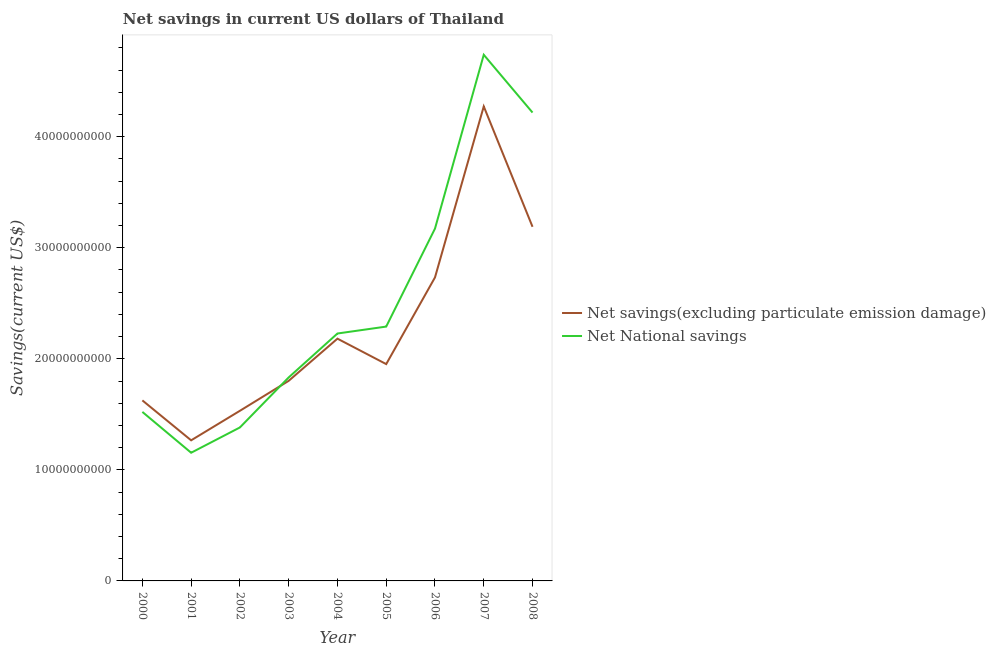Does the line corresponding to net savings(excluding particulate emission damage) intersect with the line corresponding to net national savings?
Offer a very short reply. Yes. What is the net national savings in 2008?
Provide a succinct answer. 4.22e+1. Across all years, what is the maximum net national savings?
Provide a succinct answer. 4.74e+1. Across all years, what is the minimum net national savings?
Keep it short and to the point. 1.15e+1. In which year was the net national savings maximum?
Offer a terse response. 2007. What is the total net savings(excluding particulate emission damage) in the graph?
Make the answer very short. 2.06e+11. What is the difference between the net national savings in 2003 and that in 2005?
Provide a succinct answer. -4.58e+09. What is the difference between the net savings(excluding particulate emission damage) in 2007 and the net national savings in 2002?
Your answer should be very brief. 2.89e+1. What is the average net national savings per year?
Give a very brief answer. 2.50e+1. In the year 2003, what is the difference between the net savings(excluding particulate emission damage) and net national savings?
Offer a very short reply. -3.07e+08. In how many years, is the net savings(excluding particulate emission damage) greater than 4000000000 US$?
Your answer should be compact. 9. What is the ratio of the net national savings in 2001 to that in 2002?
Your response must be concise. 0.84. Is the net national savings in 2000 less than that in 2004?
Offer a very short reply. Yes. Is the difference between the net national savings in 2003 and 2004 greater than the difference between the net savings(excluding particulate emission damage) in 2003 and 2004?
Ensure brevity in your answer.  No. What is the difference between the highest and the second highest net national savings?
Your response must be concise. 5.20e+09. What is the difference between the highest and the lowest net national savings?
Your answer should be very brief. 3.58e+1. Is the sum of the net national savings in 2000 and 2004 greater than the maximum net savings(excluding particulate emission damage) across all years?
Provide a succinct answer. No. Is the net savings(excluding particulate emission damage) strictly less than the net national savings over the years?
Provide a succinct answer. No. How many years are there in the graph?
Make the answer very short. 9. Does the graph contain any zero values?
Ensure brevity in your answer.  No. Does the graph contain grids?
Ensure brevity in your answer.  No. Where does the legend appear in the graph?
Keep it short and to the point. Center right. How many legend labels are there?
Your answer should be compact. 2. What is the title of the graph?
Ensure brevity in your answer.  Net savings in current US dollars of Thailand. Does "Under-five" appear as one of the legend labels in the graph?
Offer a very short reply. No. What is the label or title of the Y-axis?
Make the answer very short. Savings(current US$). What is the Savings(current US$) of Net savings(excluding particulate emission damage) in 2000?
Keep it short and to the point. 1.63e+1. What is the Savings(current US$) in Net National savings in 2000?
Keep it short and to the point. 1.52e+1. What is the Savings(current US$) in Net savings(excluding particulate emission damage) in 2001?
Provide a succinct answer. 1.27e+1. What is the Savings(current US$) of Net National savings in 2001?
Provide a short and direct response. 1.15e+1. What is the Savings(current US$) of Net savings(excluding particulate emission damage) in 2002?
Your answer should be compact. 1.53e+1. What is the Savings(current US$) of Net National savings in 2002?
Your answer should be very brief. 1.38e+1. What is the Savings(current US$) of Net savings(excluding particulate emission damage) in 2003?
Your response must be concise. 1.80e+1. What is the Savings(current US$) of Net National savings in 2003?
Provide a short and direct response. 1.83e+1. What is the Savings(current US$) in Net savings(excluding particulate emission damage) in 2004?
Offer a terse response. 2.18e+1. What is the Savings(current US$) in Net National savings in 2004?
Your answer should be very brief. 2.23e+1. What is the Savings(current US$) in Net savings(excluding particulate emission damage) in 2005?
Your response must be concise. 1.95e+1. What is the Savings(current US$) of Net National savings in 2005?
Offer a very short reply. 2.29e+1. What is the Savings(current US$) in Net savings(excluding particulate emission damage) in 2006?
Provide a succinct answer. 2.73e+1. What is the Savings(current US$) in Net National savings in 2006?
Your answer should be very brief. 3.17e+1. What is the Savings(current US$) in Net savings(excluding particulate emission damage) in 2007?
Your answer should be very brief. 4.27e+1. What is the Savings(current US$) in Net National savings in 2007?
Make the answer very short. 4.74e+1. What is the Savings(current US$) of Net savings(excluding particulate emission damage) in 2008?
Your answer should be compact. 3.19e+1. What is the Savings(current US$) in Net National savings in 2008?
Provide a succinct answer. 4.22e+1. Across all years, what is the maximum Savings(current US$) in Net savings(excluding particulate emission damage)?
Your response must be concise. 4.27e+1. Across all years, what is the maximum Savings(current US$) of Net National savings?
Your response must be concise. 4.74e+1. Across all years, what is the minimum Savings(current US$) in Net savings(excluding particulate emission damage)?
Your answer should be compact. 1.27e+1. Across all years, what is the minimum Savings(current US$) of Net National savings?
Give a very brief answer. 1.15e+1. What is the total Savings(current US$) of Net savings(excluding particulate emission damage) in the graph?
Your answer should be very brief. 2.06e+11. What is the total Savings(current US$) in Net National savings in the graph?
Provide a short and direct response. 2.25e+11. What is the difference between the Savings(current US$) in Net savings(excluding particulate emission damage) in 2000 and that in 2001?
Your answer should be compact. 3.60e+09. What is the difference between the Savings(current US$) in Net National savings in 2000 and that in 2001?
Keep it short and to the point. 3.68e+09. What is the difference between the Savings(current US$) in Net savings(excluding particulate emission damage) in 2000 and that in 2002?
Provide a succinct answer. 9.38e+08. What is the difference between the Savings(current US$) of Net National savings in 2000 and that in 2002?
Your response must be concise. 1.40e+09. What is the difference between the Savings(current US$) in Net savings(excluding particulate emission damage) in 2000 and that in 2003?
Your answer should be very brief. -1.76e+09. What is the difference between the Savings(current US$) of Net National savings in 2000 and that in 2003?
Provide a short and direct response. -3.10e+09. What is the difference between the Savings(current US$) in Net savings(excluding particulate emission damage) in 2000 and that in 2004?
Provide a succinct answer. -5.56e+09. What is the difference between the Savings(current US$) of Net National savings in 2000 and that in 2004?
Provide a succinct answer. -7.06e+09. What is the difference between the Savings(current US$) of Net savings(excluding particulate emission damage) in 2000 and that in 2005?
Keep it short and to the point. -3.27e+09. What is the difference between the Savings(current US$) of Net National savings in 2000 and that in 2005?
Provide a succinct answer. -7.68e+09. What is the difference between the Savings(current US$) of Net savings(excluding particulate emission damage) in 2000 and that in 2006?
Make the answer very short. -1.11e+1. What is the difference between the Savings(current US$) of Net National savings in 2000 and that in 2006?
Your answer should be compact. -1.65e+1. What is the difference between the Savings(current US$) of Net savings(excluding particulate emission damage) in 2000 and that in 2007?
Provide a succinct answer. -2.65e+1. What is the difference between the Savings(current US$) in Net National savings in 2000 and that in 2007?
Give a very brief answer. -3.22e+1. What is the difference between the Savings(current US$) of Net savings(excluding particulate emission damage) in 2000 and that in 2008?
Offer a very short reply. -1.56e+1. What is the difference between the Savings(current US$) in Net National savings in 2000 and that in 2008?
Offer a very short reply. -2.70e+1. What is the difference between the Savings(current US$) in Net savings(excluding particulate emission damage) in 2001 and that in 2002?
Offer a terse response. -2.66e+09. What is the difference between the Savings(current US$) in Net National savings in 2001 and that in 2002?
Your response must be concise. -2.28e+09. What is the difference between the Savings(current US$) in Net savings(excluding particulate emission damage) in 2001 and that in 2003?
Offer a very short reply. -5.36e+09. What is the difference between the Savings(current US$) of Net National savings in 2001 and that in 2003?
Make the answer very short. -6.78e+09. What is the difference between the Savings(current US$) in Net savings(excluding particulate emission damage) in 2001 and that in 2004?
Offer a very short reply. -9.15e+09. What is the difference between the Savings(current US$) of Net National savings in 2001 and that in 2004?
Make the answer very short. -1.07e+1. What is the difference between the Savings(current US$) of Net savings(excluding particulate emission damage) in 2001 and that in 2005?
Provide a short and direct response. -6.86e+09. What is the difference between the Savings(current US$) in Net National savings in 2001 and that in 2005?
Provide a short and direct response. -1.14e+1. What is the difference between the Savings(current US$) in Net savings(excluding particulate emission damage) in 2001 and that in 2006?
Offer a terse response. -1.47e+1. What is the difference between the Savings(current US$) of Net National savings in 2001 and that in 2006?
Keep it short and to the point. -2.02e+1. What is the difference between the Savings(current US$) of Net savings(excluding particulate emission damage) in 2001 and that in 2007?
Ensure brevity in your answer.  -3.01e+1. What is the difference between the Savings(current US$) of Net National savings in 2001 and that in 2007?
Give a very brief answer. -3.58e+1. What is the difference between the Savings(current US$) of Net savings(excluding particulate emission damage) in 2001 and that in 2008?
Ensure brevity in your answer.  -1.92e+1. What is the difference between the Savings(current US$) of Net National savings in 2001 and that in 2008?
Give a very brief answer. -3.06e+1. What is the difference between the Savings(current US$) of Net savings(excluding particulate emission damage) in 2002 and that in 2003?
Keep it short and to the point. -2.70e+09. What is the difference between the Savings(current US$) of Net National savings in 2002 and that in 2003?
Provide a succinct answer. -4.50e+09. What is the difference between the Savings(current US$) of Net savings(excluding particulate emission damage) in 2002 and that in 2004?
Your answer should be compact. -6.50e+09. What is the difference between the Savings(current US$) of Net National savings in 2002 and that in 2004?
Your answer should be very brief. -8.46e+09. What is the difference between the Savings(current US$) in Net savings(excluding particulate emission damage) in 2002 and that in 2005?
Offer a terse response. -4.20e+09. What is the difference between the Savings(current US$) in Net National savings in 2002 and that in 2005?
Ensure brevity in your answer.  -9.08e+09. What is the difference between the Savings(current US$) of Net savings(excluding particulate emission damage) in 2002 and that in 2006?
Make the answer very short. -1.20e+1. What is the difference between the Savings(current US$) of Net National savings in 2002 and that in 2006?
Your answer should be compact. -1.79e+1. What is the difference between the Savings(current US$) of Net savings(excluding particulate emission damage) in 2002 and that in 2007?
Your response must be concise. -2.74e+1. What is the difference between the Savings(current US$) in Net National savings in 2002 and that in 2007?
Your answer should be compact. -3.36e+1. What is the difference between the Savings(current US$) of Net savings(excluding particulate emission damage) in 2002 and that in 2008?
Give a very brief answer. -1.66e+1. What is the difference between the Savings(current US$) in Net National savings in 2002 and that in 2008?
Make the answer very short. -2.84e+1. What is the difference between the Savings(current US$) of Net savings(excluding particulate emission damage) in 2003 and that in 2004?
Give a very brief answer. -3.80e+09. What is the difference between the Savings(current US$) of Net National savings in 2003 and that in 2004?
Your answer should be very brief. -3.95e+09. What is the difference between the Savings(current US$) of Net savings(excluding particulate emission damage) in 2003 and that in 2005?
Your answer should be very brief. -1.51e+09. What is the difference between the Savings(current US$) of Net National savings in 2003 and that in 2005?
Your answer should be compact. -4.58e+09. What is the difference between the Savings(current US$) of Net savings(excluding particulate emission damage) in 2003 and that in 2006?
Your response must be concise. -9.31e+09. What is the difference between the Savings(current US$) in Net National savings in 2003 and that in 2006?
Ensure brevity in your answer.  -1.34e+1. What is the difference between the Savings(current US$) of Net savings(excluding particulate emission damage) in 2003 and that in 2007?
Provide a short and direct response. -2.47e+1. What is the difference between the Savings(current US$) in Net National savings in 2003 and that in 2007?
Keep it short and to the point. -2.91e+1. What is the difference between the Savings(current US$) in Net savings(excluding particulate emission damage) in 2003 and that in 2008?
Give a very brief answer. -1.39e+1. What is the difference between the Savings(current US$) in Net National savings in 2003 and that in 2008?
Your answer should be very brief. -2.38e+1. What is the difference between the Savings(current US$) in Net savings(excluding particulate emission damage) in 2004 and that in 2005?
Your answer should be compact. 2.29e+09. What is the difference between the Savings(current US$) in Net National savings in 2004 and that in 2005?
Give a very brief answer. -6.24e+08. What is the difference between the Savings(current US$) in Net savings(excluding particulate emission damage) in 2004 and that in 2006?
Keep it short and to the point. -5.51e+09. What is the difference between the Savings(current US$) of Net National savings in 2004 and that in 2006?
Offer a terse response. -9.45e+09. What is the difference between the Savings(current US$) in Net savings(excluding particulate emission damage) in 2004 and that in 2007?
Make the answer very short. -2.09e+1. What is the difference between the Savings(current US$) of Net National savings in 2004 and that in 2007?
Your response must be concise. -2.51e+1. What is the difference between the Savings(current US$) in Net savings(excluding particulate emission damage) in 2004 and that in 2008?
Give a very brief answer. -1.01e+1. What is the difference between the Savings(current US$) of Net National savings in 2004 and that in 2008?
Offer a terse response. -1.99e+1. What is the difference between the Savings(current US$) in Net savings(excluding particulate emission damage) in 2005 and that in 2006?
Your answer should be very brief. -7.80e+09. What is the difference between the Savings(current US$) in Net National savings in 2005 and that in 2006?
Your answer should be compact. -8.82e+09. What is the difference between the Savings(current US$) in Net savings(excluding particulate emission damage) in 2005 and that in 2007?
Your response must be concise. -2.32e+1. What is the difference between the Savings(current US$) in Net National savings in 2005 and that in 2007?
Give a very brief answer. -2.45e+1. What is the difference between the Savings(current US$) in Net savings(excluding particulate emission damage) in 2005 and that in 2008?
Offer a terse response. -1.24e+1. What is the difference between the Savings(current US$) of Net National savings in 2005 and that in 2008?
Keep it short and to the point. -1.93e+1. What is the difference between the Savings(current US$) of Net savings(excluding particulate emission damage) in 2006 and that in 2007?
Give a very brief answer. -1.54e+1. What is the difference between the Savings(current US$) of Net National savings in 2006 and that in 2007?
Give a very brief answer. -1.57e+1. What is the difference between the Savings(current US$) of Net savings(excluding particulate emission damage) in 2006 and that in 2008?
Provide a short and direct response. -4.56e+09. What is the difference between the Savings(current US$) of Net National savings in 2006 and that in 2008?
Your response must be concise. -1.04e+1. What is the difference between the Savings(current US$) of Net savings(excluding particulate emission damage) in 2007 and that in 2008?
Keep it short and to the point. 1.08e+1. What is the difference between the Savings(current US$) of Net National savings in 2007 and that in 2008?
Provide a short and direct response. 5.20e+09. What is the difference between the Savings(current US$) of Net savings(excluding particulate emission damage) in 2000 and the Savings(current US$) of Net National savings in 2001?
Your response must be concise. 4.71e+09. What is the difference between the Savings(current US$) in Net savings(excluding particulate emission damage) in 2000 and the Savings(current US$) in Net National savings in 2002?
Give a very brief answer. 2.44e+09. What is the difference between the Savings(current US$) in Net savings(excluding particulate emission damage) in 2000 and the Savings(current US$) in Net National savings in 2003?
Make the answer very short. -2.07e+09. What is the difference between the Savings(current US$) in Net savings(excluding particulate emission damage) in 2000 and the Savings(current US$) in Net National savings in 2004?
Your answer should be very brief. -6.02e+09. What is the difference between the Savings(current US$) of Net savings(excluding particulate emission damage) in 2000 and the Savings(current US$) of Net National savings in 2005?
Your response must be concise. -6.65e+09. What is the difference between the Savings(current US$) of Net savings(excluding particulate emission damage) in 2000 and the Savings(current US$) of Net National savings in 2006?
Your answer should be compact. -1.55e+1. What is the difference between the Savings(current US$) in Net savings(excluding particulate emission damage) in 2000 and the Savings(current US$) in Net National savings in 2007?
Ensure brevity in your answer.  -3.11e+1. What is the difference between the Savings(current US$) of Net savings(excluding particulate emission damage) in 2000 and the Savings(current US$) of Net National savings in 2008?
Ensure brevity in your answer.  -2.59e+1. What is the difference between the Savings(current US$) of Net savings(excluding particulate emission damage) in 2001 and the Savings(current US$) of Net National savings in 2002?
Ensure brevity in your answer.  -1.16e+09. What is the difference between the Savings(current US$) in Net savings(excluding particulate emission damage) in 2001 and the Savings(current US$) in Net National savings in 2003?
Your answer should be compact. -5.66e+09. What is the difference between the Savings(current US$) of Net savings(excluding particulate emission damage) in 2001 and the Savings(current US$) of Net National savings in 2004?
Provide a short and direct response. -9.62e+09. What is the difference between the Savings(current US$) of Net savings(excluding particulate emission damage) in 2001 and the Savings(current US$) of Net National savings in 2005?
Your response must be concise. -1.02e+1. What is the difference between the Savings(current US$) in Net savings(excluding particulate emission damage) in 2001 and the Savings(current US$) in Net National savings in 2006?
Provide a succinct answer. -1.91e+1. What is the difference between the Savings(current US$) of Net savings(excluding particulate emission damage) in 2001 and the Savings(current US$) of Net National savings in 2007?
Make the answer very short. -3.47e+1. What is the difference between the Savings(current US$) in Net savings(excluding particulate emission damage) in 2001 and the Savings(current US$) in Net National savings in 2008?
Provide a succinct answer. -2.95e+1. What is the difference between the Savings(current US$) of Net savings(excluding particulate emission damage) in 2002 and the Savings(current US$) of Net National savings in 2003?
Your response must be concise. -3.00e+09. What is the difference between the Savings(current US$) in Net savings(excluding particulate emission damage) in 2002 and the Savings(current US$) in Net National savings in 2004?
Provide a short and direct response. -6.96e+09. What is the difference between the Savings(current US$) of Net savings(excluding particulate emission damage) in 2002 and the Savings(current US$) of Net National savings in 2005?
Your response must be concise. -7.58e+09. What is the difference between the Savings(current US$) of Net savings(excluding particulate emission damage) in 2002 and the Savings(current US$) of Net National savings in 2006?
Your response must be concise. -1.64e+1. What is the difference between the Savings(current US$) in Net savings(excluding particulate emission damage) in 2002 and the Savings(current US$) in Net National savings in 2007?
Offer a very short reply. -3.21e+1. What is the difference between the Savings(current US$) of Net savings(excluding particulate emission damage) in 2002 and the Savings(current US$) of Net National savings in 2008?
Make the answer very short. -2.69e+1. What is the difference between the Savings(current US$) in Net savings(excluding particulate emission damage) in 2003 and the Savings(current US$) in Net National savings in 2004?
Your response must be concise. -4.26e+09. What is the difference between the Savings(current US$) of Net savings(excluding particulate emission damage) in 2003 and the Savings(current US$) of Net National savings in 2005?
Offer a very short reply. -4.89e+09. What is the difference between the Savings(current US$) of Net savings(excluding particulate emission damage) in 2003 and the Savings(current US$) of Net National savings in 2006?
Provide a succinct answer. -1.37e+1. What is the difference between the Savings(current US$) in Net savings(excluding particulate emission damage) in 2003 and the Savings(current US$) in Net National savings in 2007?
Make the answer very short. -2.94e+1. What is the difference between the Savings(current US$) of Net savings(excluding particulate emission damage) in 2003 and the Savings(current US$) of Net National savings in 2008?
Provide a short and direct response. -2.42e+1. What is the difference between the Savings(current US$) in Net savings(excluding particulate emission damage) in 2004 and the Savings(current US$) in Net National savings in 2005?
Give a very brief answer. -1.09e+09. What is the difference between the Savings(current US$) in Net savings(excluding particulate emission damage) in 2004 and the Savings(current US$) in Net National savings in 2006?
Your response must be concise. -9.91e+09. What is the difference between the Savings(current US$) of Net savings(excluding particulate emission damage) in 2004 and the Savings(current US$) of Net National savings in 2007?
Your response must be concise. -2.56e+1. What is the difference between the Savings(current US$) in Net savings(excluding particulate emission damage) in 2004 and the Savings(current US$) in Net National savings in 2008?
Make the answer very short. -2.04e+1. What is the difference between the Savings(current US$) in Net savings(excluding particulate emission damage) in 2005 and the Savings(current US$) in Net National savings in 2006?
Your answer should be very brief. -1.22e+1. What is the difference between the Savings(current US$) in Net savings(excluding particulate emission damage) in 2005 and the Savings(current US$) in Net National savings in 2007?
Keep it short and to the point. -2.79e+1. What is the difference between the Savings(current US$) in Net savings(excluding particulate emission damage) in 2005 and the Savings(current US$) in Net National savings in 2008?
Keep it short and to the point. -2.26e+1. What is the difference between the Savings(current US$) in Net savings(excluding particulate emission damage) in 2006 and the Savings(current US$) in Net National savings in 2007?
Provide a succinct answer. -2.00e+1. What is the difference between the Savings(current US$) in Net savings(excluding particulate emission damage) in 2006 and the Savings(current US$) in Net National savings in 2008?
Provide a succinct answer. -1.48e+1. What is the difference between the Savings(current US$) of Net savings(excluding particulate emission damage) in 2007 and the Savings(current US$) of Net National savings in 2008?
Give a very brief answer. 5.54e+08. What is the average Savings(current US$) in Net savings(excluding particulate emission damage) per year?
Your response must be concise. 2.28e+1. What is the average Savings(current US$) of Net National savings per year?
Offer a terse response. 2.50e+1. In the year 2000, what is the difference between the Savings(current US$) in Net savings(excluding particulate emission damage) and Savings(current US$) in Net National savings?
Ensure brevity in your answer.  1.04e+09. In the year 2001, what is the difference between the Savings(current US$) of Net savings(excluding particulate emission damage) and Savings(current US$) of Net National savings?
Keep it short and to the point. 1.12e+09. In the year 2002, what is the difference between the Savings(current US$) of Net savings(excluding particulate emission damage) and Savings(current US$) of Net National savings?
Your response must be concise. 1.50e+09. In the year 2003, what is the difference between the Savings(current US$) in Net savings(excluding particulate emission damage) and Savings(current US$) in Net National savings?
Offer a terse response. -3.07e+08. In the year 2004, what is the difference between the Savings(current US$) of Net savings(excluding particulate emission damage) and Savings(current US$) of Net National savings?
Keep it short and to the point. -4.63e+08. In the year 2005, what is the difference between the Savings(current US$) of Net savings(excluding particulate emission damage) and Savings(current US$) of Net National savings?
Make the answer very short. -3.38e+09. In the year 2006, what is the difference between the Savings(current US$) in Net savings(excluding particulate emission damage) and Savings(current US$) in Net National savings?
Make the answer very short. -4.40e+09. In the year 2007, what is the difference between the Savings(current US$) in Net savings(excluding particulate emission damage) and Savings(current US$) in Net National savings?
Keep it short and to the point. -4.65e+09. In the year 2008, what is the difference between the Savings(current US$) in Net savings(excluding particulate emission damage) and Savings(current US$) in Net National savings?
Offer a very short reply. -1.03e+1. What is the ratio of the Savings(current US$) of Net savings(excluding particulate emission damage) in 2000 to that in 2001?
Offer a terse response. 1.28. What is the ratio of the Savings(current US$) of Net National savings in 2000 to that in 2001?
Provide a succinct answer. 1.32. What is the ratio of the Savings(current US$) in Net savings(excluding particulate emission damage) in 2000 to that in 2002?
Provide a succinct answer. 1.06. What is the ratio of the Savings(current US$) of Net National savings in 2000 to that in 2002?
Offer a terse response. 1.1. What is the ratio of the Savings(current US$) in Net savings(excluding particulate emission damage) in 2000 to that in 2003?
Your answer should be compact. 0.9. What is the ratio of the Savings(current US$) of Net National savings in 2000 to that in 2003?
Offer a very short reply. 0.83. What is the ratio of the Savings(current US$) in Net savings(excluding particulate emission damage) in 2000 to that in 2004?
Keep it short and to the point. 0.75. What is the ratio of the Savings(current US$) in Net National savings in 2000 to that in 2004?
Make the answer very short. 0.68. What is the ratio of the Savings(current US$) of Net savings(excluding particulate emission damage) in 2000 to that in 2005?
Provide a short and direct response. 0.83. What is the ratio of the Savings(current US$) of Net National savings in 2000 to that in 2005?
Provide a succinct answer. 0.66. What is the ratio of the Savings(current US$) of Net savings(excluding particulate emission damage) in 2000 to that in 2006?
Give a very brief answer. 0.59. What is the ratio of the Savings(current US$) in Net National savings in 2000 to that in 2006?
Your answer should be compact. 0.48. What is the ratio of the Savings(current US$) in Net savings(excluding particulate emission damage) in 2000 to that in 2007?
Give a very brief answer. 0.38. What is the ratio of the Savings(current US$) of Net National savings in 2000 to that in 2007?
Your answer should be very brief. 0.32. What is the ratio of the Savings(current US$) of Net savings(excluding particulate emission damage) in 2000 to that in 2008?
Offer a terse response. 0.51. What is the ratio of the Savings(current US$) of Net National savings in 2000 to that in 2008?
Your response must be concise. 0.36. What is the ratio of the Savings(current US$) of Net savings(excluding particulate emission damage) in 2001 to that in 2002?
Offer a terse response. 0.83. What is the ratio of the Savings(current US$) of Net National savings in 2001 to that in 2002?
Give a very brief answer. 0.84. What is the ratio of the Savings(current US$) in Net savings(excluding particulate emission damage) in 2001 to that in 2003?
Offer a terse response. 0.7. What is the ratio of the Savings(current US$) in Net National savings in 2001 to that in 2003?
Make the answer very short. 0.63. What is the ratio of the Savings(current US$) of Net savings(excluding particulate emission damage) in 2001 to that in 2004?
Ensure brevity in your answer.  0.58. What is the ratio of the Savings(current US$) of Net National savings in 2001 to that in 2004?
Your answer should be compact. 0.52. What is the ratio of the Savings(current US$) of Net savings(excluding particulate emission damage) in 2001 to that in 2005?
Your answer should be very brief. 0.65. What is the ratio of the Savings(current US$) in Net National savings in 2001 to that in 2005?
Keep it short and to the point. 0.5. What is the ratio of the Savings(current US$) in Net savings(excluding particulate emission damage) in 2001 to that in 2006?
Provide a short and direct response. 0.46. What is the ratio of the Savings(current US$) of Net National savings in 2001 to that in 2006?
Provide a succinct answer. 0.36. What is the ratio of the Savings(current US$) of Net savings(excluding particulate emission damage) in 2001 to that in 2007?
Keep it short and to the point. 0.3. What is the ratio of the Savings(current US$) in Net National savings in 2001 to that in 2007?
Provide a succinct answer. 0.24. What is the ratio of the Savings(current US$) of Net savings(excluding particulate emission damage) in 2001 to that in 2008?
Offer a terse response. 0.4. What is the ratio of the Savings(current US$) in Net National savings in 2001 to that in 2008?
Offer a terse response. 0.27. What is the ratio of the Savings(current US$) in Net savings(excluding particulate emission damage) in 2002 to that in 2003?
Offer a very short reply. 0.85. What is the ratio of the Savings(current US$) in Net National savings in 2002 to that in 2003?
Provide a short and direct response. 0.75. What is the ratio of the Savings(current US$) of Net savings(excluding particulate emission damage) in 2002 to that in 2004?
Provide a succinct answer. 0.7. What is the ratio of the Savings(current US$) in Net National savings in 2002 to that in 2004?
Give a very brief answer. 0.62. What is the ratio of the Savings(current US$) of Net savings(excluding particulate emission damage) in 2002 to that in 2005?
Your answer should be very brief. 0.78. What is the ratio of the Savings(current US$) of Net National savings in 2002 to that in 2005?
Provide a short and direct response. 0.6. What is the ratio of the Savings(current US$) of Net savings(excluding particulate emission damage) in 2002 to that in 2006?
Provide a succinct answer. 0.56. What is the ratio of the Savings(current US$) in Net National savings in 2002 to that in 2006?
Give a very brief answer. 0.44. What is the ratio of the Savings(current US$) of Net savings(excluding particulate emission damage) in 2002 to that in 2007?
Your answer should be compact. 0.36. What is the ratio of the Savings(current US$) of Net National savings in 2002 to that in 2007?
Offer a very short reply. 0.29. What is the ratio of the Savings(current US$) in Net savings(excluding particulate emission damage) in 2002 to that in 2008?
Your answer should be compact. 0.48. What is the ratio of the Savings(current US$) in Net National savings in 2002 to that in 2008?
Your answer should be very brief. 0.33. What is the ratio of the Savings(current US$) in Net savings(excluding particulate emission damage) in 2003 to that in 2004?
Provide a short and direct response. 0.83. What is the ratio of the Savings(current US$) of Net National savings in 2003 to that in 2004?
Your response must be concise. 0.82. What is the ratio of the Savings(current US$) of Net savings(excluding particulate emission damage) in 2003 to that in 2005?
Your answer should be compact. 0.92. What is the ratio of the Savings(current US$) in Net National savings in 2003 to that in 2005?
Your answer should be very brief. 0.8. What is the ratio of the Savings(current US$) of Net savings(excluding particulate emission damage) in 2003 to that in 2006?
Your answer should be very brief. 0.66. What is the ratio of the Savings(current US$) of Net National savings in 2003 to that in 2006?
Your response must be concise. 0.58. What is the ratio of the Savings(current US$) of Net savings(excluding particulate emission damage) in 2003 to that in 2007?
Provide a succinct answer. 0.42. What is the ratio of the Savings(current US$) of Net National savings in 2003 to that in 2007?
Make the answer very short. 0.39. What is the ratio of the Savings(current US$) in Net savings(excluding particulate emission damage) in 2003 to that in 2008?
Make the answer very short. 0.56. What is the ratio of the Savings(current US$) of Net National savings in 2003 to that in 2008?
Provide a short and direct response. 0.43. What is the ratio of the Savings(current US$) in Net savings(excluding particulate emission damage) in 2004 to that in 2005?
Offer a very short reply. 1.12. What is the ratio of the Savings(current US$) in Net National savings in 2004 to that in 2005?
Provide a short and direct response. 0.97. What is the ratio of the Savings(current US$) in Net savings(excluding particulate emission damage) in 2004 to that in 2006?
Your response must be concise. 0.8. What is the ratio of the Savings(current US$) of Net National savings in 2004 to that in 2006?
Provide a succinct answer. 0.7. What is the ratio of the Savings(current US$) of Net savings(excluding particulate emission damage) in 2004 to that in 2007?
Give a very brief answer. 0.51. What is the ratio of the Savings(current US$) of Net National savings in 2004 to that in 2007?
Your answer should be very brief. 0.47. What is the ratio of the Savings(current US$) in Net savings(excluding particulate emission damage) in 2004 to that in 2008?
Offer a terse response. 0.68. What is the ratio of the Savings(current US$) of Net National savings in 2004 to that in 2008?
Your response must be concise. 0.53. What is the ratio of the Savings(current US$) of Net savings(excluding particulate emission damage) in 2005 to that in 2006?
Make the answer very short. 0.71. What is the ratio of the Savings(current US$) in Net National savings in 2005 to that in 2006?
Make the answer very short. 0.72. What is the ratio of the Savings(current US$) in Net savings(excluding particulate emission damage) in 2005 to that in 2007?
Ensure brevity in your answer.  0.46. What is the ratio of the Savings(current US$) in Net National savings in 2005 to that in 2007?
Offer a terse response. 0.48. What is the ratio of the Savings(current US$) in Net savings(excluding particulate emission damage) in 2005 to that in 2008?
Keep it short and to the point. 0.61. What is the ratio of the Savings(current US$) in Net National savings in 2005 to that in 2008?
Your response must be concise. 0.54. What is the ratio of the Savings(current US$) in Net savings(excluding particulate emission damage) in 2006 to that in 2007?
Give a very brief answer. 0.64. What is the ratio of the Savings(current US$) of Net National savings in 2006 to that in 2007?
Your answer should be compact. 0.67. What is the ratio of the Savings(current US$) of Net savings(excluding particulate emission damage) in 2006 to that in 2008?
Give a very brief answer. 0.86. What is the ratio of the Savings(current US$) of Net National savings in 2006 to that in 2008?
Your response must be concise. 0.75. What is the ratio of the Savings(current US$) in Net savings(excluding particulate emission damage) in 2007 to that in 2008?
Your answer should be compact. 1.34. What is the ratio of the Savings(current US$) of Net National savings in 2007 to that in 2008?
Ensure brevity in your answer.  1.12. What is the difference between the highest and the second highest Savings(current US$) of Net savings(excluding particulate emission damage)?
Keep it short and to the point. 1.08e+1. What is the difference between the highest and the second highest Savings(current US$) in Net National savings?
Your response must be concise. 5.20e+09. What is the difference between the highest and the lowest Savings(current US$) in Net savings(excluding particulate emission damage)?
Provide a short and direct response. 3.01e+1. What is the difference between the highest and the lowest Savings(current US$) of Net National savings?
Provide a short and direct response. 3.58e+1. 